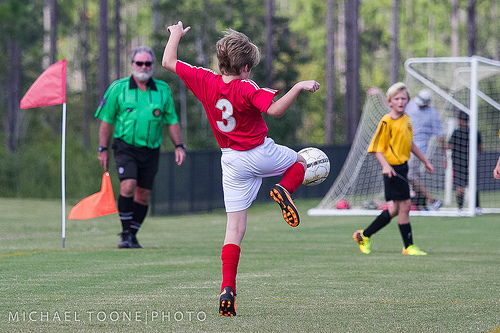<image>
Is there a ball in front of the shoe? Yes. The ball is positioned in front of the shoe, appearing closer to the camera viewpoint. 